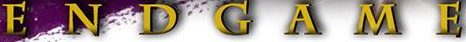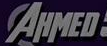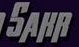What words are shown in these images in order, separated by a semicolon? ENDGAME; AHMED; SAHR 